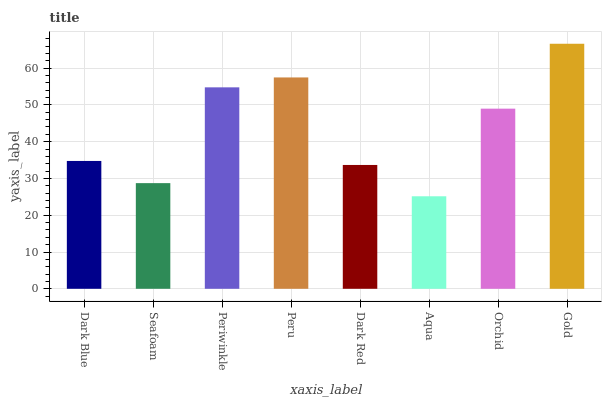Is Aqua the minimum?
Answer yes or no. Yes. Is Gold the maximum?
Answer yes or no. Yes. Is Seafoam the minimum?
Answer yes or no. No. Is Seafoam the maximum?
Answer yes or no. No. Is Dark Blue greater than Seafoam?
Answer yes or no. Yes. Is Seafoam less than Dark Blue?
Answer yes or no. Yes. Is Seafoam greater than Dark Blue?
Answer yes or no. No. Is Dark Blue less than Seafoam?
Answer yes or no. No. Is Orchid the high median?
Answer yes or no. Yes. Is Dark Blue the low median?
Answer yes or no. Yes. Is Gold the high median?
Answer yes or no. No. Is Gold the low median?
Answer yes or no. No. 